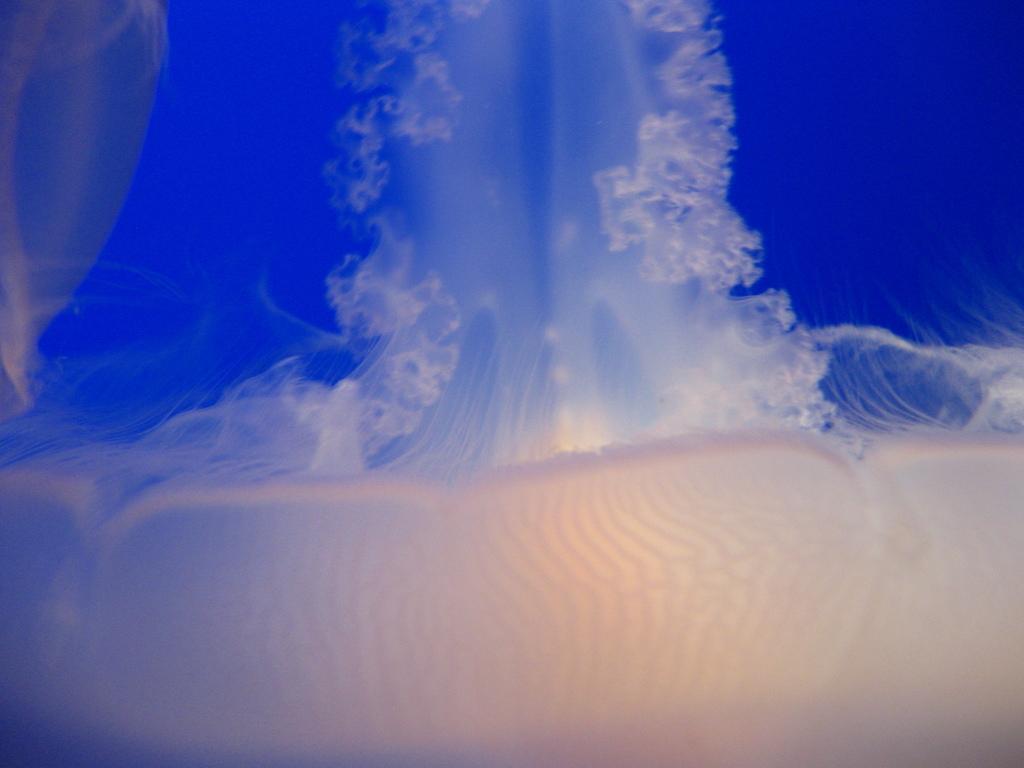How would you summarize this image in a sentence or two? In this image we can see jellyfish in the water. 